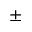Convert formula to latex. <formula><loc_0><loc_0><loc_500><loc_500>\pm</formula> 